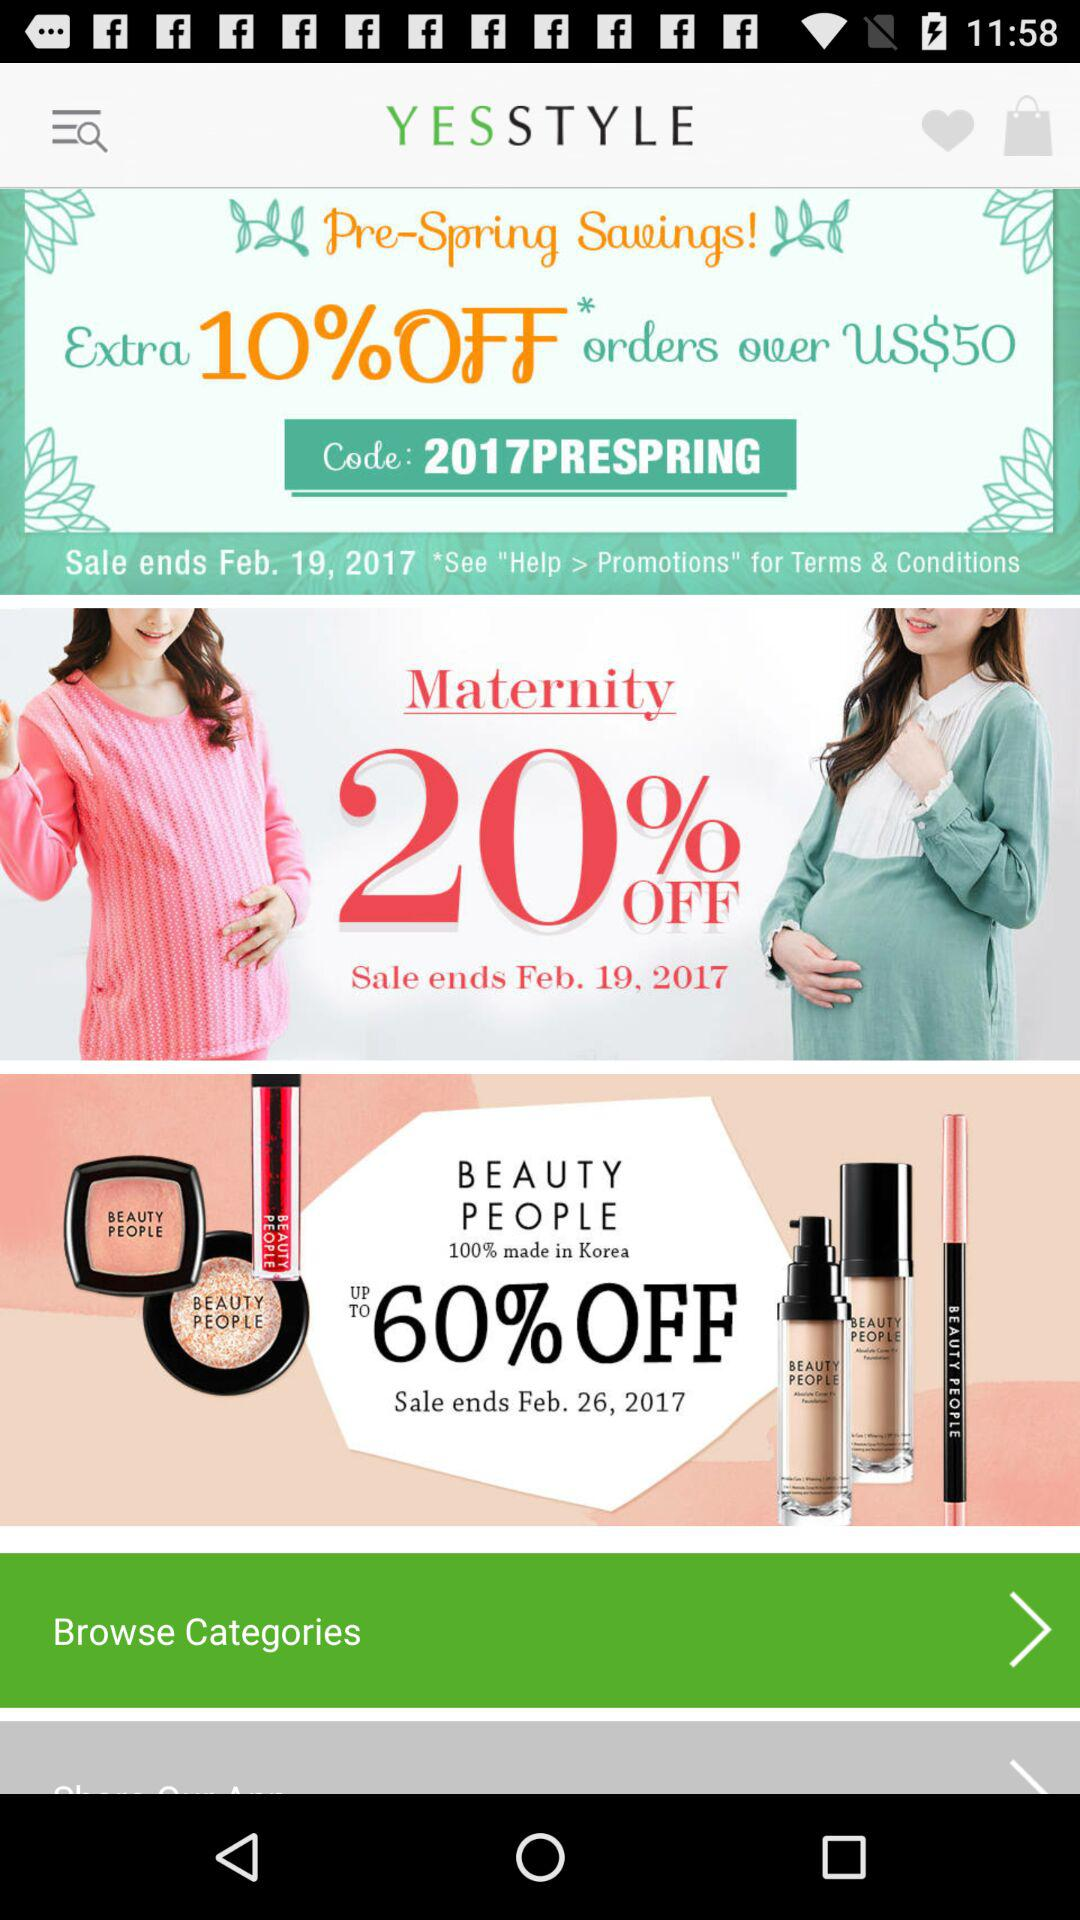On what date does the "Pre-Spring Savings" sale end? The "Pre-Spring Savings" sale ends on Feb. 19, 2017. 